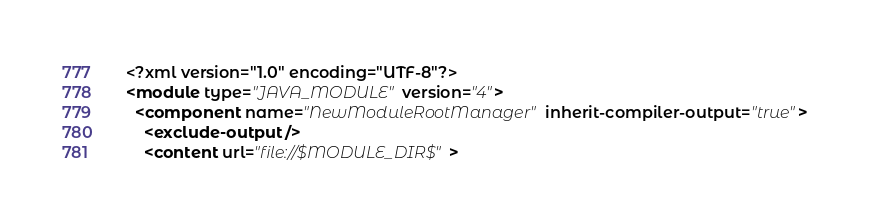<code> <loc_0><loc_0><loc_500><loc_500><_XML_><?xml version="1.0" encoding="UTF-8"?>
<module type="JAVA_MODULE" version="4">
  <component name="NewModuleRootManager" inherit-compiler-output="true">
    <exclude-output />
    <content url="file://$MODULE_DIR$"></code> 